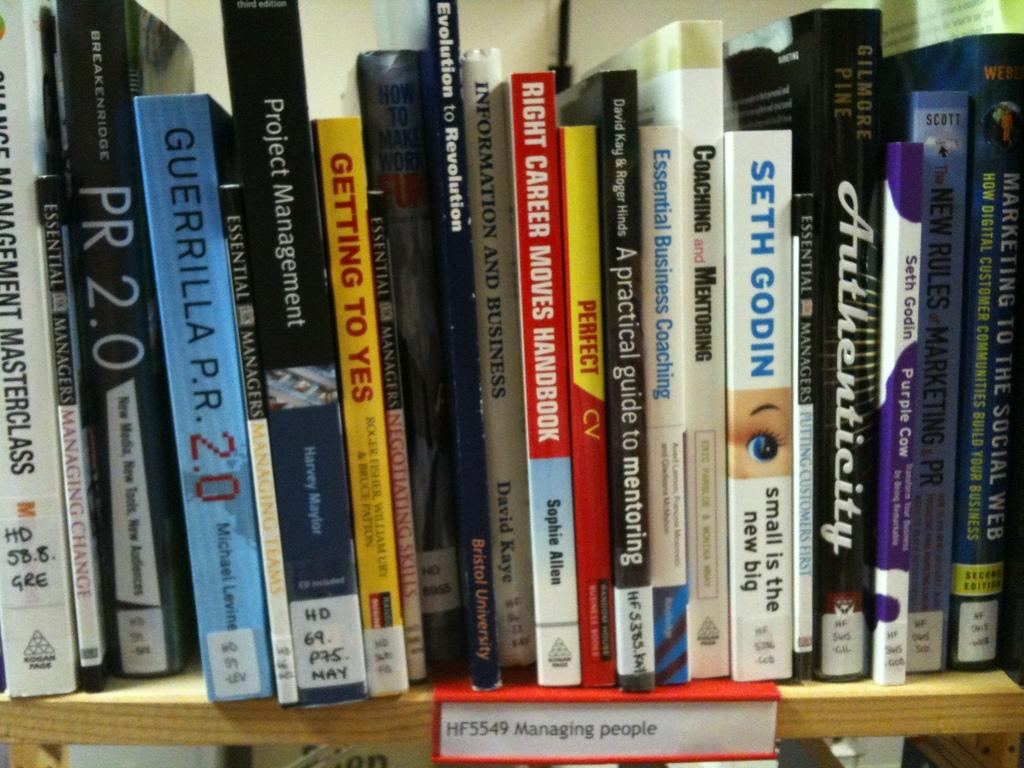<image>
Describe the image concisely. A shelf full of books, one of which is by Seth Godin. 